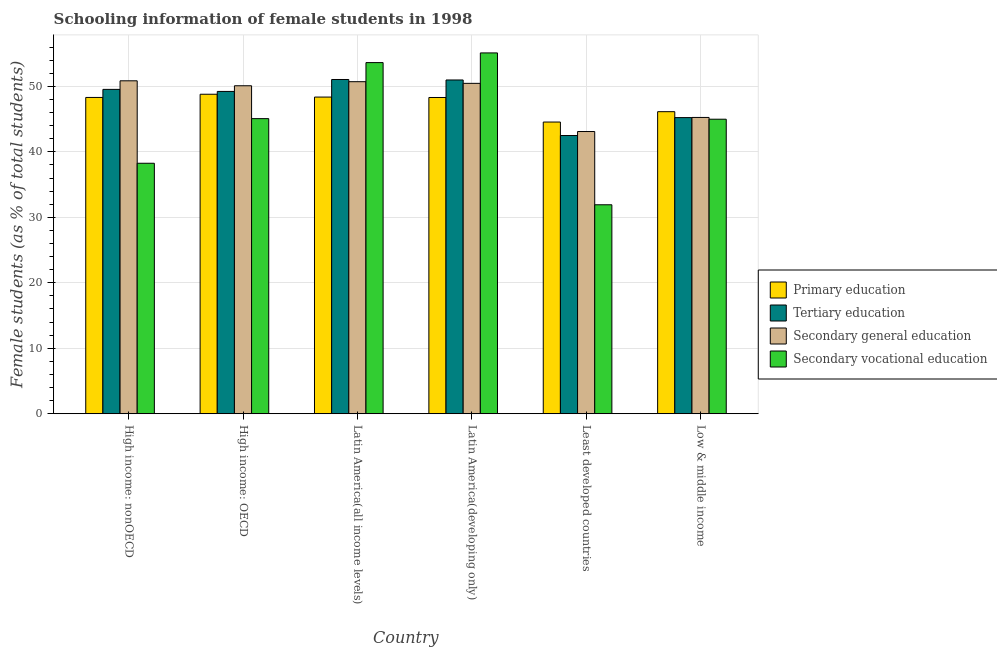How many different coloured bars are there?
Your answer should be very brief. 4. How many groups of bars are there?
Make the answer very short. 6. What is the label of the 5th group of bars from the left?
Your answer should be compact. Least developed countries. In how many cases, is the number of bars for a given country not equal to the number of legend labels?
Ensure brevity in your answer.  0. What is the percentage of female students in secondary education in Least developed countries?
Your answer should be compact. 43.11. Across all countries, what is the maximum percentage of female students in primary education?
Provide a short and direct response. 48.8. Across all countries, what is the minimum percentage of female students in secondary vocational education?
Offer a very short reply. 31.92. In which country was the percentage of female students in secondary education maximum?
Your answer should be very brief. High income: nonOECD. In which country was the percentage of female students in secondary vocational education minimum?
Offer a very short reply. Least developed countries. What is the total percentage of female students in tertiary education in the graph?
Give a very brief answer. 288.53. What is the difference between the percentage of female students in tertiary education in High income: nonOECD and that in Low & middle income?
Your response must be concise. 4.31. What is the difference between the percentage of female students in tertiary education in High income: nonOECD and the percentage of female students in secondary education in Low & middle income?
Make the answer very short. 4.28. What is the average percentage of female students in secondary education per country?
Provide a succinct answer. 48.42. What is the difference between the percentage of female students in secondary education and percentage of female students in tertiary education in Latin America(all income levels)?
Your answer should be very brief. -0.34. What is the ratio of the percentage of female students in primary education in Least developed countries to that in Low & middle income?
Provide a short and direct response. 0.97. Is the percentage of female students in secondary education in Latin America(developing only) less than that in Least developed countries?
Your answer should be very brief. No. What is the difference between the highest and the second highest percentage of female students in secondary education?
Ensure brevity in your answer.  0.14. What is the difference between the highest and the lowest percentage of female students in tertiary education?
Offer a very short reply. 8.56. In how many countries, is the percentage of female students in primary education greater than the average percentage of female students in primary education taken over all countries?
Your response must be concise. 4. Is it the case that in every country, the sum of the percentage of female students in secondary vocational education and percentage of female students in primary education is greater than the sum of percentage of female students in tertiary education and percentage of female students in secondary education?
Your answer should be compact. No. What does the 1st bar from the left in High income: OECD represents?
Provide a succinct answer. Primary education. What does the 1st bar from the right in High income: nonOECD represents?
Your answer should be compact. Secondary vocational education. How many bars are there?
Keep it short and to the point. 24. Are all the bars in the graph horizontal?
Give a very brief answer. No. What is the difference between two consecutive major ticks on the Y-axis?
Give a very brief answer. 10. How are the legend labels stacked?
Ensure brevity in your answer.  Vertical. What is the title of the graph?
Your response must be concise. Schooling information of female students in 1998. Does "Primary" appear as one of the legend labels in the graph?
Provide a succinct answer. No. What is the label or title of the X-axis?
Ensure brevity in your answer.  Country. What is the label or title of the Y-axis?
Your response must be concise. Female students (as % of total students). What is the Female students (as % of total students) of Primary education in High income: nonOECD?
Your response must be concise. 48.31. What is the Female students (as % of total students) of Tertiary education in High income: nonOECD?
Make the answer very short. 49.54. What is the Female students (as % of total students) of Secondary general education in High income: nonOECD?
Offer a very short reply. 50.85. What is the Female students (as % of total students) of Secondary vocational education in High income: nonOECD?
Your answer should be very brief. 38.26. What is the Female students (as % of total students) in Primary education in High income: OECD?
Your response must be concise. 48.8. What is the Female students (as % of total students) in Tertiary education in High income: OECD?
Your answer should be very brief. 49.23. What is the Female students (as % of total students) of Secondary general education in High income: OECD?
Give a very brief answer. 50.1. What is the Female students (as % of total students) of Secondary vocational education in High income: OECD?
Provide a short and direct response. 45.07. What is the Female students (as % of total students) in Primary education in Latin America(all income levels)?
Make the answer very short. 48.37. What is the Female students (as % of total students) in Tertiary education in Latin America(all income levels)?
Make the answer very short. 51.05. What is the Female students (as % of total students) of Secondary general education in Latin America(all income levels)?
Make the answer very short. 50.72. What is the Female students (as % of total students) of Secondary vocational education in Latin America(all income levels)?
Keep it short and to the point. 53.63. What is the Female students (as % of total students) in Primary education in Latin America(developing only)?
Give a very brief answer. 48.3. What is the Female students (as % of total students) of Tertiary education in Latin America(developing only)?
Your response must be concise. 50.98. What is the Female students (as % of total students) in Secondary general education in Latin America(developing only)?
Ensure brevity in your answer.  50.46. What is the Female students (as % of total students) in Secondary vocational education in Latin America(developing only)?
Make the answer very short. 55.11. What is the Female students (as % of total students) of Primary education in Least developed countries?
Your answer should be very brief. 44.55. What is the Female students (as % of total students) in Tertiary education in Least developed countries?
Give a very brief answer. 42.49. What is the Female students (as % of total students) in Secondary general education in Least developed countries?
Your response must be concise. 43.11. What is the Female students (as % of total students) in Secondary vocational education in Least developed countries?
Offer a terse response. 31.92. What is the Female students (as % of total students) in Primary education in Low & middle income?
Keep it short and to the point. 46.14. What is the Female students (as % of total students) in Tertiary education in Low & middle income?
Your answer should be compact. 45.23. What is the Female students (as % of total students) in Secondary general education in Low & middle income?
Provide a succinct answer. 45.26. What is the Female students (as % of total students) of Secondary vocational education in Low & middle income?
Keep it short and to the point. 44.99. Across all countries, what is the maximum Female students (as % of total students) in Primary education?
Give a very brief answer. 48.8. Across all countries, what is the maximum Female students (as % of total students) in Tertiary education?
Provide a short and direct response. 51.05. Across all countries, what is the maximum Female students (as % of total students) in Secondary general education?
Your response must be concise. 50.85. Across all countries, what is the maximum Female students (as % of total students) of Secondary vocational education?
Offer a very short reply. 55.11. Across all countries, what is the minimum Female students (as % of total students) in Primary education?
Your answer should be compact. 44.55. Across all countries, what is the minimum Female students (as % of total students) in Tertiary education?
Your response must be concise. 42.49. Across all countries, what is the minimum Female students (as % of total students) of Secondary general education?
Your response must be concise. 43.11. Across all countries, what is the minimum Female students (as % of total students) of Secondary vocational education?
Offer a terse response. 31.92. What is the total Female students (as % of total students) in Primary education in the graph?
Your response must be concise. 284.47. What is the total Female students (as % of total students) of Tertiary education in the graph?
Keep it short and to the point. 288.53. What is the total Female students (as % of total students) of Secondary general education in the graph?
Offer a very short reply. 290.49. What is the total Female students (as % of total students) of Secondary vocational education in the graph?
Provide a short and direct response. 268.98. What is the difference between the Female students (as % of total students) of Primary education in High income: nonOECD and that in High income: OECD?
Make the answer very short. -0.49. What is the difference between the Female students (as % of total students) in Tertiary education in High income: nonOECD and that in High income: OECD?
Provide a succinct answer. 0.31. What is the difference between the Female students (as % of total students) of Secondary general education in High income: nonOECD and that in High income: OECD?
Give a very brief answer. 0.76. What is the difference between the Female students (as % of total students) of Secondary vocational education in High income: nonOECD and that in High income: OECD?
Your answer should be compact. -6.81. What is the difference between the Female students (as % of total students) in Primary education in High income: nonOECD and that in Latin America(all income levels)?
Offer a terse response. -0.06. What is the difference between the Female students (as % of total students) of Tertiary education in High income: nonOECD and that in Latin America(all income levels)?
Make the answer very short. -1.51. What is the difference between the Female students (as % of total students) of Secondary general education in High income: nonOECD and that in Latin America(all income levels)?
Offer a very short reply. 0.14. What is the difference between the Female students (as % of total students) in Secondary vocational education in High income: nonOECD and that in Latin America(all income levels)?
Your response must be concise. -15.37. What is the difference between the Female students (as % of total students) of Primary education in High income: nonOECD and that in Latin America(developing only)?
Your response must be concise. 0.01. What is the difference between the Female students (as % of total students) of Tertiary education in High income: nonOECD and that in Latin America(developing only)?
Your response must be concise. -1.44. What is the difference between the Female students (as % of total students) of Secondary general education in High income: nonOECD and that in Latin America(developing only)?
Provide a succinct answer. 0.39. What is the difference between the Female students (as % of total students) in Secondary vocational education in High income: nonOECD and that in Latin America(developing only)?
Your answer should be compact. -16.85. What is the difference between the Female students (as % of total students) of Primary education in High income: nonOECD and that in Least developed countries?
Ensure brevity in your answer.  3.76. What is the difference between the Female students (as % of total students) of Tertiary education in High income: nonOECD and that in Least developed countries?
Keep it short and to the point. 7.05. What is the difference between the Female students (as % of total students) in Secondary general education in High income: nonOECD and that in Least developed countries?
Provide a succinct answer. 7.75. What is the difference between the Female students (as % of total students) of Secondary vocational education in High income: nonOECD and that in Least developed countries?
Your answer should be very brief. 6.34. What is the difference between the Female students (as % of total students) of Primary education in High income: nonOECD and that in Low & middle income?
Provide a short and direct response. 2.17. What is the difference between the Female students (as % of total students) in Tertiary education in High income: nonOECD and that in Low & middle income?
Give a very brief answer. 4.31. What is the difference between the Female students (as % of total students) of Secondary general education in High income: nonOECD and that in Low & middle income?
Keep it short and to the point. 5.6. What is the difference between the Female students (as % of total students) in Secondary vocational education in High income: nonOECD and that in Low & middle income?
Offer a very short reply. -6.73. What is the difference between the Female students (as % of total students) in Primary education in High income: OECD and that in Latin America(all income levels)?
Provide a short and direct response. 0.43. What is the difference between the Female students (as % of total students) in Tertiary education in High income: OECD and that in Latin America(all income levels)?
Give a very brief answer. -1.82. What is the difference between the Female students (as % of total students) in Secondary general education in High income: OECD and that in Latin America(all income levels)?
Keep it short and to the point. -0.62. What is the difference between the Female students (as % of total students) of Secondary vocational education in High income: OECD and that in Latin America(all income levels)?
Ensure brevity in your answer.  -8.56. What is the difference between the Female students (as % of total students) in Primary education in High income: OECD and that in Latin America(developing only)?
Offer a very short reply. 0.49. What is the difference between the Female students (as % of total students) in Tertiary education in High income: OECD and that in Latin America(developing only)?
Give a very brief answer. -1.75. What is the difference between the Female students (as % of total students) of Secondary general education in High income: OECD and that in Latin America(developing only)?
Your answer should be compact. -0.37. What is the difference between the Female students (as % of total students) of Secondary vocational education in High income: OECD and that in Latin America(developing only)?
Give a very brief answer. -10.04. What is the difference between the Female students (as % of total students) of Primary education in High income: OECD and that in Least developed countries?
Give a very brief answer. 4.25. What is the difference between the Female students (as % of total students) in Tertiary education in High income: OECD and that in Least developed countries?
Your response must be concise. 6.74. What is the difference between the Female students (as % of total students) of Secondary general education in High income: OECD and that in Least developed countries?
Your answer should be very brief. 6.99. What is the difference between the Female students (as % of total students) in Secondary vocational education in High income: OECD and that in Least developed countries?
Your answer should be compact. 13.16. What is the difference between the Female students (as % of total students) in Primary education in High income: OECD and that in Low & middle income?
Your response must be concise. 2.66. What is the difference between the Female students (as % of total students) in Tertiary education in High income: OECD and that in Low & middle income?
Provide a succinct answer. 4. What is the difference between the Female students (as % of total students) of Secondary general education in High income: OECD and that in Low & middle income?
Provide a succinct answer. 4.84. What is the difference between the Female students (as % of total students) in Secondary vocational education in High income: OECD and that in Low & middle income?
Provide a succinct answer. 0.09. What is the difference between the Female students (as % of total students) in Primary education in Latin America(all income levels) and that in Latin America(developing only)?
Offer a very short reply. 0.06. What is the difference between the Female students (as % of total students) in Tertiary education in Latin America(all income levels) and that in Latin America(developing only)?
Your answer should be compact. 0.07. What is the difference between the Female students (as % of total students) of Secondary general education in Latin America(all income levels) and that in Latin America(developing only)?
Provide a succinct answer. 0.25. What is the difference between the Female students (as % of total students) of Secondary vocational education in Latin America(all income levels) and that in Latin America(developing only)?
Provide a short and direct response. -1.48. What is the difference between the Female students (as % of total students) in Primary education in Latin America(all income levels) and that in Least developed countries?
Make the answer very short. 3.81. What is the difference between the Female students (as % of total students) of Tertiary education in Latin America(all income levels) and that in Least developed countries?
Your response must be concise. 8.56. What is the difference between the Female students (as % of total students) of Secondary general education in Latin America(all income levels) and that in Least developed countries?
Keep it short and to the point. 7.61. What is the difference between the Female students (as % of total students) in Secondary vocational education in Latin America(all income levels) and that in Least developed countries?
Offer a very short reply. 21.72. What is the difference between the Female students (as % of total students) of Primary education in Latin America(all income levels) and that in Low & middle income?
Ensure brevity in your answer.  2.23. What is the difference between the Female students (as % of total students) of Tertiary education in Latin America(all income levels) and that in Low & middle income?
Offer a terse response. 5.82. What is the difference between the Female students (as % of total students) of Secondary general education in Latin America(all income levels) and that in Low & middle income?
Provide a succinct answer. 5.46. What is the difference between the Female students (as % of total students) in Secondary vocational education in Latin America(all income levels) and that in Low & middle income?
Offer a terse response. 8.65. What is the difference between the Female students (as % of total students) of Primary education in Latin America(developing only) and that in Least developed countries?
Make the answer very short. 3.75. What is the difference between the Female students (as % of total students) of Tertiary education in Latin America(developing only) and that in Least developed countries?
Provide a succinct answer. 8.49. What is the difference between the Female students (as % of total students) in Secondary general education in Latin America(developing only) and that in Least developed countries?
Ensure brevity in your answer.  7.36. What is the difference between the Female students (as % of total students) in Secondary vocational education in Latin America(developing only) and that in Least developed countries?
Offer a very short reply. 23.2. What is the difference between the Female students (as % of total students) of Primary education in Latin America(developing only) and that in Low & middle income?
Your response must be concise. 2.17. What is the difference between the Female students (as % of total students) of Tertiary education in Latin America(developing only) and that in Low & middle income?
Keep it short and to the point. 5.75. What is the difference between the Female students (as % of total students) in Secondary general education in Latin America(developing only) and that in Low & middle income?
Ensure brevity in your answer.  5.21. What is the difference between the Female students (as % of total students) of Secondary vocational education in Latin America(developing only) and that in Low & middle income?
Provide a succinct answer. 10.13. What is the difference between the Female students (as % of total students) in Primary education in Least developed countries and that in Low & middle income?
Your answer should be compact. -1.58. What is the difference between the Female students (as % of total students) in Tertiary education in Least developed countries and that in Low & middle income?
Offer a very short reply. -2.74. What is the difference between the Female students (as % of total students) in Secondary general education in Least developed countries and that in Low & middle income?
Your answer should be very brief. -2.15. What is the difference between the Female students (as % of total students) in Secondary vocational education in Least developed countries and that in Low & middle income?
Make the answer very short. -13.07. What is the difference between the Female students (as % of total students) in Primary education in High income: nonOECD and the Female students (as % of total students) in Tertiary education in High income: OECD?
Give a very brief answer. -0.92. What is the difference between the Female students (as % of total students) in Primary education in High income: nonOECD and the Female students (as % of total students) in Secondary general education in High income: OECD?
Provide a short and direct response. -1.79. What is the difference between the Female students (as % of total students) of Primary education in High income: nonOECD and the Female students (as % of total students) of Secondary vocational education in High income: OECD?
Offer a very short reply. 3.24. What is the difference between the Female students (as % of total students) in Tertiary education in High income: nonOECD and the Female students (as % of total students) in Secondary general education in High income: OECD?
Your answer should be compact. -0.56. What is the difference between the Female students (as % of total students) in Tertiary education in High income: nonOECD and the Female students (as % of total students) in Secondary vocational education in High income: OECD?
Provide a short and direct response. 4.47. What is the difference between the Female students (as % of total students) of Secondary general education in High income: nonOECD and the Female students (as % of total students) of Secondary vocational education in High income: OECD?
Keep it short and to the point. 5.78. What is the difference between the Female students (as % of total students) of Primary education in High income: nonOECD and the Female students (as % of total students) of Tertiary education in Latin America(all income levels)?
Offer a very short reply. -2.74. What is the difference between the Female students (as % of total students) of Primary education in High income: nonOECD and the Female students (as % of total students) of Secondary general education in Latin America(all income levels)?
Make the answer very short. -2.41. What is the difference between the Female students (as % of total students) in Primary education in High income: nonOECD and the Female students (as % of total students) in Secondary vocational education in Latin America(all income levels)?
Keep it short and to the point. -5.32. What is the difference between the Female students (as % of total students) of Tertiary education in High income: nonOECD and the Female students (as % of total students) of Secondary general education in Latin America(all income levels)?
Your answer should be very brief. -1.17. What is the difference between the Female students (as % of total students) in Tertiary education in High income: nonOECD and the Female students (as % of total students) in Secondary vocational education in Latin America(all income levels)?
Your answer should be very brief. -4.09. What is the difference between the Female students (as % of total students) of Secondary general education in High income: nonOECD and the Female students (as % of total students) of Secondary vocational education in Latin America(all income levels)?
Make the answer very short. -2.78. What is the difference between the Female students (as % of total students) of Primary education in High income: nonOECD and the Female students (as % of total students) of Tertiary education in Latin America(developing only)?
Provide a succinct answer. -2.67. What is the difference between the Female students (as % of total students) of Primary education in High income: nonOECD and the Female students (as % of total students) of Secondary general education in Latin America(developing only)?
Ensure brevity in your answer.  -2.15. What is the difference between the Female students (as % of total students) in Primary education in High income: nonOECD and the Female students (as % of total students) in Secondary vocational education in Latin America(developing only)?
Keep it short and to the point. -6.8. What is the difference between the Female students (as % of total students) of Tertiary education in High income: nonOECD and the Female students (as % of total students) of Secondary general education in Latin America(developing only)?
Your answer should be very brief. -0.92. What is the difference between the Female students (as % of total students) of Tertiary education in High income: nonOECD and the Female students (as % of total students) of Secondary vocational education in Latin America(developing only)?
Provide a short and direct response. -5.57. What is the difference between the Female students (as % of total students) in Secondary general education in High income: nonOECD and the Female students (as % of total students) in Secondary vocational education in Latin America(developing only)?
Your response must be concise. -4.26. What is the difference between the Female students (as % of total students) in Primary education in High income: nonOECD and the Female students (as % of total students) in Tertiary education in Least developed countries?
Offer a terse response. 5.82. What is the difference between the Female students (as % of total students) of Primary education in High income: nonOECD and the Female students (as % of total students) of Secondary general education in Least developed countries?
Your answer should be very brief. 5.2. What is the difference between the Female students (as % of total students) in Primary education in High income: nonOECD and the Female students (as % of total students) in Secondary vocational education in Least developed countries?
Keep it short and to the point. 16.39. What is the difference between the Female students (as % of total students) in Tertiary education in High income: nonOECD and the Female students (as % of total students) in Secondary general education in Least developed countries?
Your answer should be very brief. 6.44. What is the difference between the Female students (as % of total students) in Tertiary education in High income: nonOECD and the Female students (as % of total students) in Secondary vocational education in Least developed countries?
Make the answer very short. 17.62. What is the difference between the Female students (as % of total students) of Secondary general education in High income: nonOECD and the Female students (as % of total students) of Secondary vocational education in Least developed countries?
Give a very brief answer. 18.94. What is the difference between the Female students (as % of total students) of Primary education in High income: nonOECD and the Female students (as % of total students) of Tertiary education in Low & middle income?
Give a very brief answer. 3.08. What is the difference between the Female students (as % of total students) in Primary education in High income: nonOECD and the Female students (as % of total students) in Secondary general education in Low & middle income?
Offer a terse response. 3.05. What is the difference between the Female students (as % of total students) in Primary education in High income: nonOECD and the Female students (as % of total students) in Secondary vocational education in Low & middle income?
Provide a succinct answer. 3.32. What is the difference between the Female students (as % of total students) in Tertiary education in High income: nonOECD and the Female students (as % of total students) in Secondary general education in Low & middle income?
Give a very brief answer. 4.28. What is the difference between the Female students (as % of total students) in Tertiary education in High income: nonOECD and the Female students (as % of total students) in Secondary vocational education in Low & middle income?
Your answer should be compact. 4.55. What is the difference between the Female students (as % of total students) of Secondary general education in High income: nonOECD and the Female students (as % of total students) of Secondary vocational education in Low & middle income?
Keep it short and to the point. 5.87. What is the difference between the Female students (as % of total students) of Primary education in High income: OECD and the Female students (as % of total students) of Tertiary education in Latin America(all income levels)?
Keep it short and to the point. -2.25. What is the difference between the Female students (as % of total students) of Primary education in High income: OECD and the Female students (as % of total students) of Secondary general education in Latin America(all income levels)?
Make the answer very short. -1.92. What is the difference between the Female students (as % of total students) of Primary education in High income: OECD and the Female students (as % of total students) of Secondary vocational education in Latin America(all income levels)?
Make the answer very short. -4.83. What is the difference between the Female students (as % of total students) in Tertiary education in High income: OECD and the Female students (as % of total students) in Secondary general education in Latin America(all income levels)?
Provide a short and direct response. -1.49. What is the difference between the Female students (as % of total students) in Tertiary education in High income: OECD and the Female students (as % of total students) in Secondary vocational education in Latin America(all income levels)?
Your answer should be very brief. -4.4. What is the difference between the Female students (as % of total students) in Secondary general education in High income: OECD and the Female students (as % of total students) in Secondary vocational education in Latin America(all income levels)?
Give a very brief answer. -3.54. What is the difference between the Female students (as % of total students) of Primary education in High income: OECD and the Female students (as % of total students) of Tertiary education in Latin America(developing only)?
Ensure brevity in your answer.  -2.18. What is the difference between the Female students (as % of total students) of Primary education in High income: OECD and the Female students (as % of total students) of Secondary general education in Latin America(developing only)?
Your response must be concise. -1.66. What is the difference between the Female students (as % of total students) of Primary education in High income: OECD and the Female students (as % of total students) of Secondary vocational education in Latin America(developing only)?
Provide a short and direct response. -6.31. What is the difference between the Female students (as % of total students) of Tertiary education in High income: OECD and the Female students (as % of total students) of Secondary general education in Latin America(developing only)?
Provide a succinct answer. -1.23. What is the difference between the Female students (as % of total students) in Tertiary education in High income: OECD and the Female students (as % of total students) in Secondary vocational education in Latin America(developing only)?
Keep it short and to the point. -5.88. What is the difference between the Female students (as % of total students) of Secondary general education in High income: OECD and the Female students (as % of total students) of Secondary vocational education in Latin America(developing only)?
Your answer should be very brief. -5.02. What is the difference between the Female students (as % of total students) in Primary education in High income: OECD and the Female students (as % of total students) in Tertiary education in Least developed countries?
Provide a succinct answer. 6.31. What is the difference between the Female students (as % of total students) of Primary education in High income: OECD and the Female students (as % of total students) of Secondary general education in Least developed countries?
Your response must be concise. 5.69. What is the difference between the Female students (as % of total students) of Primary education in High income: OECD and the Female students (as % of total students) of Secondary vocational education in Least developed countries?
Keep it short and to the point. 16.88. What is the difference between the Female students (as % of total students) in Tertiary education in High income: OECD and the Female students (as % of total students) in Secondary general education in Least developed countries?
Provide a succinct answer. 6.12. What is the difference between the Female students (as % of total students) of Tertiary education in High income: OECD and the Female students (as % of total students) of Secondary vocational education in Least developed countries?
Make the answer very short. 17.31. What is the difference between the Female students (as % of total students) in Secondary general education in High income: OECD and the Female students (as % of total students) in Secondary vocational education in Least developed countries?
Offer a very short reply. 18.18. What is the difference between the Female students (as % of total students) of Primary education in High income: OECD and the Female students (as % of total students) of Tertiary education in Low & middle income?
Your response must be concise. 3.57. What is the difference between the Female students (as % of total students) in Primary education in High income: OECD and the Female students (as % of total students) in Secondary general education in Low & middle income?
Ensure brevity in your answer.  3.54. What is the difference between the Female students (as % of total students) of Primary education in High income: OECD and the Female students (as % of total students) of Secondary vocational education in Low & middle income?
Give a very brief answer. 3.81. What is the difference between the Female students (as % of total students) in Tertiary education in High income: OECD and the Female students (as % of total students) in Secondary general education in Low & middle income?
Your answer should be very brief. 3.97. What is the difference between the Female students (as % of total students) in Tertiary education in High income: OECD and the Female students (as % of total students) in Secondary vocational education in Low & middle income?
Provide a short and direct response. 4.24. What is the difference between the Female students (as % of total students) in Secondary general education in High income: OECD and the Female students (as % of total students) in Secondary vocational education in Low & middle income?
Your answer should be very brief. 5.11. What is the difference between the Female students (as % of total students) in Primary education in Latin America(all income levels) and the Female students (as % of total students) in Tertiary education in Latin America(developing only)?
Keep it short and to the point. -2.61. What is the difference between the Female students (as % of total students) in Primary education in Latin America(all income levels) and the Female students (as % of total students) in Secondary general education in Latin America(developing only)?
Provide a short and direct response. -2.1. What is the difference between the Female students (as % of total students) in Primary education in Latin America(all income levels) and the Female students (as % of total students) in Secondary vocational education in Latin America(developing only)?
Provide a short and direct response. -6.74. What is the difference between the Female students (as % of total students) in Tertiary education in Latin America(all income levels) and the Female students (as % of total students) in Secondary general education in Latin America(developing only)?
Provide a succinct answer. 0.59. What is the difference between the Female students (as % of total students) of Tertiary education in Latin America(all income levels) and the Female students (as % of total students) of Secondary vocational education in Latin America(developing only)?
Provide a succinct answer. -4.06. What is the difference between the Female students (as % of total students) of Secondary general education in Latin America(all income levels) and the Female students (as % of total students) of Secondary vocational education in Latin America(developing only)?
Provide a short and direct response. -4.4. What is the difference between the Female students (as % of total students) in Primary education in Latin America(all income levels) and the Female students (as % of total students) in Tertiary education in Least developed countries?
Offer a terse response. 5.87. What is the difference between the Female students (as % of total students) of Primary education in Latin America(all income levels) and the Female students (as % of total students) of Secondary general education in Least developed countries?
Make the answer very short. 5.26. What is the difference between the Female students (as % of total students) in Primary education in Latin America(all income levels) and the Female students (as % of total students) in Secondary vocational education in Least developed countries?
Give a very brief answer. 16.45. What is the difference between the Female students (as % of total students) in Tertiary education in Latin America(all income levels) and the Female students (as % of total students) in Secondary general education in Least developed countries?
Provide a short and direct response. 7.95. What is the difference between the Female students (as % of total students) in Tertiary education in Latin America(all income levels) and the Female students (as % of total students) in Secondary vocational education in Least developed countries?
Your answer should be compact. 19.14. What is the difference between the Female students (as % of total students) in Secondary general education in Latin America(all income levels) and the Female students (as % of total students) in Secondary vocational education in Least developed countries?
Your response must be concise. 18.8. What is the difference between the Female students (as % of total students) in Primary education in Latin America(all income levels) and the Female students (as % of total students) in Tertiary education in Low & middle income?
Make the answer very short. 3.14. What is the difference between the Female students (as % of total students) in Primary education in Latin America(all income levels) and the Female students (as % of total students) in Secondary general education in Low & middle income?
Make the answer very short. 3.11. What is the difference between the Female students (as % of total students) in Primary education in Latin America(all income levels) and the Female students (as % of total students) in Secondary vocational education in Low & middle income?
Your answer should be very brief. 3.38. What is the difference between the Female students (as % of total students) of Tertiary education in Latin America(all income levels) and the Female students (as % of total students) of Secondary general education in Low & middle income?
Provide a short and direct response. 5.8. What is the difference between the Female students (as % of total students) of Tertiary education in Latin America(all income levels) and the Female students (as % of total students) of Secondary vocational education in Low & middle income?
Offer a terse response. 6.07. What is the difference between the Female students (as % of total students) of Secondary general education in Latin America(all income levels) and the Female students (as % of total students) of Secondary vocational education in Low & middle income?
Your response must be concise. 5.73. What is the difference between the Female students (as % of total students) in Primary education in Latin America(developing only) and the Female students (as % of total students) in Tertiary education in Least developed countries?
Provide a short and direct response. 5.81. What is the difference between the Female students (as % of total students) of Primary education in Latin America(developing only) and the Female students (as % of total students) of Secondary general education in Least developed countries?
Provide a short and direct response. 5.2. What is the difference between the Female students (as % of total students) of Primary education in Latin America(developing only) and the Female students (as % of total students) of Secondary vocational education in Least developed countries?
Your answer should be compact. 16.39. What is the difference between the Female students (as % of total students) of Tertiary education in Latin America(developing only) and the Female students (as % of total students) of Secondary general education in Least developed countries?
Make the answer very short. 7.87. What is the difference between the Female students (as % of total students) of Tertiary education in Latin America(developing only) and the Female students (as % of total students) of Secondary vocational education in Least developed countries?
Keep it short and to the point. 19.06. What is the difference between the Female students (as % of total students) of Secondary general education in Latin America(developing only) and the Female students (as % of total students) of Secondary vocational education in Least developed countries?
Your answer should be very brief. 18.55. What is the difference between the Female students (as % of total students) in Primary education in Latin America(developing only) and the Female students (as % of total students) in Tertiary education in Low & middle income?
Offer a very short reply. 3.07. What is the difference between the Female students (as % of total students) of Primary education in Latin America(developing only) and the Female students (as % of total students) of Secondary general education in Low & middle income?
Your answer should be compact. 3.05. What is the difference between the Female students (as % of total students) of Primary education in Latin America(developing only) and the Female students (as % of total students) of Secondary vocational education in Low & middle income?
Make the answer very short. 3.32. What is the difference between the Female students (as % of total students) of Tertiary education in Latin America(developing only) and the Female students (as % of total students) of Secondary general education in Low & middle income?
Your response must be concise. 5.72. What is the difference between the Female students (as % of total students) of Tertiary education in Latin America(developing only) and the Female students (as % of total students) of Secondary vocational education in Low & middle income?
Ensure brevity in your answer.  5.99. What is the difference between the Female students (as % of total students) in Secondary general education in Latin America(developing only) and the Female students (as % of total students) in Secondary vocational education in Low & middle income?
Your answer should be compact. 5.48. What is the difference between the Female students (as % of total students) in Primary education in Least developed countries and the Female students (as % of total students) in Tertiary education in Low & middle income?
Offer a terse response. -0.68. What is the difference between the Female students (as % of total students) of Primary education in Least developed countries and the Female students (as % of total students) of Secondary general education in Low & middle income?
Your response must be concise. -0.7. What is the difference between the Female students (as % of total students) in Primary education in Least developed countries and the Female students (as % of total students) in Secondary vocational education in Low & middle income?
Ensure brevity in your answer.  -0.43. What is the difference between the Female students (as % of total students) of Tertiary education in Least developed countries and the Female students (as % of total students) of Secondary general education in Low & middle income?
Make the answer very short. -2.76. What is the difference between the Female students (as % of total students) in Tertiary education in Least developed countries and the Female students (as % of total students) in Secondary vocational education in Low & middle income?
Offer a very short reply. -2.49. What is the difference between the Female students (as % of total students) of Secondary general education in Least developed countries and the Female students (as % of total students) of Secondary vocational education in Low & middle income?
Offer a terse response. -1.88. What is the average Female students (as % of total students) in Primary education per country?
Provide a succinct answer. 47.41. What is the average Female students (as % of total students) in Tertiary education per country?
Make the answer very short. 48.09. What is the average Female students (as % of total students) in Secondary general education per country?
Your answer should be compact. 48.42. What is the average Female students (as % of total students) of Secondary vocational education per country?
Provide a succinct answer. 44.83. What is the difference between the Female students (as % of total students) in Primary education and Female students (as % of total students) in Tertiary education in High income: nonOECD?
Give a very brief answer. -1.23. What is the difference between the Female students (as % of total students) of Primary education and Female students (as % of total students) of Secondary general education in High income: nonOECD?
Give a very brief answer. -2.54. What is the difference between the Female students (as % of total students) of Primary education and Female students (as % of total students) of Secondary vocational education in High income: nonOECD?
Offer a very short reply. 10.05. What is the difference between the Female students (as % of total students) in Tertiary education and Female students (as % of total students) in Secondary general education in High income: nonOECD?
Your answer should be compact. -1.31. What is the difference between the Female students (as % of total students) in Tertiary education and Female students (as % of total students) in Secondary vocational education in High income: nonOECD?
Your response must be concise. 11.28. What is the difference between the Female students (as % of total students) in Secondary general education and Female students (as % of total students) in Secondary vocational education in High income: nonOECD?
Provide a succinct answer. 12.59. What is the difference between the Female students (as % of total students) of Primary education and Female students (as % of total students) of Tertiary education in High income: OECD?
Provide a succinct answer. -0.43. What is the difference between the Female students (as % of total students) in Primary education and Female students (as % of total students) in Secondary general education in High income: OECD?
Offer a terse response. -1.3. What is the difference between the Female students (as % of total students) of Primary education and Female students (as % of total students) of Secondary vocational education in High income: OECD?
Offer a very short reply. 3.73. What is the difference between the Female students (as % of total students) in Tertiary education and Female students (as % of total students) in Secondary general education in High income: OECD?
Offer a terse response. -0.87. What is the difference between the Female students (as % of total students) of Tertiary education and Female students (as % of total students) of Secondary vocational education in High income: OECD?
Offer a very short reply. 4.16. What is the difference between the Female students (as % of total students) of Secondary general education and Female students (as % of total students) of Secondary vocational education in High income: OECD?
Ensure brevity in your answer.  5.02. What is the difference between the Female students (as % of total students) of Primary education and Female students (as % of total students) of Tertiary education in Latin America(all income levels)?
Your response must be concise. -2.68. What is the difference between the Female students (as % of total students) of Primary education and Female students (as % of total students) of Secondary general education in Latin America(all income levels)?
Offer a terse response. -2.35. What is the difference between the Female students (as % of total students) in Primary education and Female students (as % of total students) in Secondary vocational education in Latin America(all income levels)?
Provide a short and direct response. -5.26. What is the difference between the Female students (as % of total students) of Tertiary education and Female students (as % of total students) of Secondary general education in Latin America(all income levels)?
Your answer should be very brief. 0.34. What is the difference between the Female students (as % of total students) in Tertiary education and Female students (as % of total students) in Secondary vocational education in Latin America(all income levels)?
Keep it short and to the point. -2.58. What is the difference between the Female students (as % of total students) in Secondary general education and Female students (as % of total students) in Secondary vocational education in Latin America(all income levels)?
Give a very brief answer. -2.92. What is the difference between the Female students (as % of total students) in Primary education and Female students (as % of total students) in Tertiary education in Latin America(developing only)?
Keep it short and to the point. -2.67. What is the difference between the Female students (as % of total students) in Primary education and Female students (as % of total students) in Secondary general education in Latin America(developing only)?
Keep it short and to the point. -2.16. What is the difference between the Female students (as % of total students) of Primary education and Female students (as % of total students) of Secondary vocational education in Latin America(developing only)?
Provide a succinct answer. -6.81. What is the difference between the Female students (as % of total students) in Tertiary education and Female students (as % of total students) in Secondary general education in Latin America(developing only)?
Make the answer very short. 0.52. What is the difference between the Female students (as % of total students) of Tertiary education and Female students (as % of total students) of Secondary vocational education in Latin America(developing only)?
Offer a terse response. -4.13. What is the difference between the Female students (as % of total students) in Secondary general education and Female students (as % of total students) in Secondary vocational education in Latin America(developing only)?
Keep it short and to the point. -4.65. What is the difference between the Female students (as % of total students) of Primary education and Female students (as % of total students) of Tertiary education in Least developed countries?
Keep it short and to the point. 2.06. What is the difference between the Female students (as % of total students) of Primary education and Female students (as % of total students) of Secondary general education in Least developed countries?
Your response must be concise. 1.45. What is the difference between the Female students (as % of total students) in Primary education and Female students (as % of total students) in Secondary vocational education in Least developed countries?
Provide a succinct answer. 12.64. What is the difference between the Female students (as % of total students) of Tertiary education and Female students (as % of total students) of Secondary general education in Least developed countries?
Your response must be concise. -0.61. What is the difference between the Female students (as % of total students) in Tertiary education and Female students (as % of total students) in Secondary vocational education in Least developed countries?
Provide a succinct answer. 10.58. What is the difference between the Female students (as % of total students) of Secondary general education and Female students (as % of total students) of Secondary vocational education in Least developed countries?
Offer a terse response. 11.19. What is the difference between the Female students (as % of total students) of Primary education and Female students (as % of total students) of Tertiary education in Low & middle income?
Provide a short and direct response. 0.9. What is the difference between the Female students (as % of total students) of Primary education and Female students (as % of total students) of Secondary general education in Low & middle income?
Offer a very short reply. 0.88. What is the difference between the Female students (as % of total students) in Primary education and Female students (as % of total students) in Secondary vocational education in Low & middle income?
Provide a short and direct response. 1.15. What is the difference between the Female students (as % of total students) of Tertiary education and Female students (as % of total students) of Secondary general education in Low & middle income?
Your answer should be very brief. -0.03. What is the difference between the Female students (as % of total students) of Tertiary education and Female students (as % of total students) of Secondary vocational education in Low & middle income?
Make the answer very short. 0.25. What is the difference between the Female students (as % of total students) of Secondary general education and Female students (as % of total students) of Secondary vocational education in Low & middle income?
Provide a short and direct response. 0.27. What is the ratio of the Female students (as % of total students) of Primary education in High income: nonOECD to that in High income: OECD?
Offer a very short reply. 0.99. What is the ratio of the Female students (as % of total students) in Secondary general education in High income: nonOECD to that in High income: OECD?
Ensure brevity in your answer.  1.02. What is the ratio of the Female students (as % of total students) of Secondary vocational education in High income: nonOECD to that in High income: OECD?
Provide a succinct answer. 0.85. What is the ratio of the Female students (as % of total students) of Primary education in High income: nonOECD to that in Latin America(all income levels)?
Your response must be concise. 1. What is the ratio of the Female students (as % of total students) in Tertiary education in High income: nonOECD to that in Latin America(all income levels)?
Give a very brief answer. 0.97. What is the ratio of the Female students (as % of total students) in Secondary vocational education in High income: nonOECD to that in Latin America(all income levels)?
Your answer should be compact. 0.71. What is the ratio of the Female students (as % of total students) in Primary education in High income: nonOECD to that in Latin America(developing only)?
Give a very brief answer. 1. What is the ratio of the Female students (as % of total students) of Tertiary education in High income: nonOECD to that in Latin America(developing only)?
Provide a succinct answer. 0.97. What is the ratio of the Female students (as % of total students) in Secondary general education in High income: nonOECD to that in Latin America(developing only)?
Make the answer very short. 1.01. What is the ratio of the Female students (as % of total students) of Secondary vocational education in High income: nonOECD to that in Latin America(developing only)?
Your response must be concise. 0.69. What is the ratio of the Female students (as % of total students) in Primary education in High income: nonOECD to that in Least developed countries?
Your answer should be very brief. 1.08. What is the ratio of the Female students (as % of total students) in Tertiary education in High income: nonOECD to that in Least developed countries?
Ensure brevity in your answer.  1.17. What is the ratio of the Female students (as % of total students) in Secondary general education in High income: nonOECD to that in Least developed countries?
Make the answer very short. 1.18. What is the ratio of the Female students (as % of total students) of Secondary vocational education in High income: nonOECD to that in Least developed countries?
Your response must be concise. 1.2. What is the ratio of the Female students (as % of total students) in Primary education in High income: nonOECD to that in Low & middle income?
Your response must be concise. 1.05. What is the ratio of the Female students (as % of total students) in Tertiary education in High income: nonOECD to that in Low & middle income?
Offer a very short reply. 1.1. What is the ratio of the Female students (as % of total students) in Secondary general education in High income: nonOECD to that in Low & middle income?
Offer a very short reply. 1.12. What is the ratio of the Female students (as % of total students) of Secondary vocational education in High income: nonOECD to that in Low & middle income?
Your answer should be very brief. 0.85. What is the ratio of the Female students (as % of total students) in Primary education in High income: OECD to that in Latin America(all income levels)?
Ensure brevity in your answer.  1.01. What is the ratio of the Female students (as % of total students) in Tertiary education in High income: OECD to that in Latin America(all income levels)?
Your answer should be very brief. 0.96. What is the ratio of the Female students (as % of total students) in Secondary general education in High income: OECD to that in Latin America(all income levels)?
Ensure brevity in your answer.  0.99. What is the ratio of the Female students (as % of total students) of Secondary vocational education in High income: OECD to that in Latin America(all income levels)?
Keep it short and to the point. 0.84. What is the ratio of the Female students (as % of total students) in Primary education in High income: OECD to that in Latin America(developing only)?
Offer a very short reply. 1.01. What is the ratio of the Female students (as % of total students) in Tertiary education in High income: OECD to that in Latin America(developing only)?
Provide a short and direct response. 0.97. What is the ratio of the Female students (as % of total students) of Secondary vocational education in High income: OECD to that in Latin America(developing only)?
Your answer should be compact. 0.82. What is the ratio of the Female students (as % of total students) in Primary education in High income: OECD to that in Least developed countries?
Keep it short and to the point. 1.1. What is the ratio of the Female students (as % of total students) in Tertiary education in High income: OECD to that in Least developed countries?
Your response must be concise. 1.16. What is the ratio of the Female students (as % of total students) of Secondary general education in High income: OECD to that in Least developed countries?
Offer a very short reply. 1.16. What is the ratio of the Female students (as % of total students) of Secondary vocational education in High income: OECD to that in Least developed countries?
Keep it short and to the point. 1.41. What is the ratio of the Female students (as % of total students) of Primary education in High income: OECD to that in Low & middle income?
Provide a short and direct response. 1.06. What is the ratio of the Female students (as % of total students) in Tertiary education in High income: OECD to that in Low & middle income?
Give a very brief answer. 1.09. What is the ratio of the Female students (as % of total students) in Secondary general education in High income: OECD to that in Low & middle income?
Keep it short and to the point. 1.11. What is the ratio of the Female students (as % of total students) of Secondary vocational education in High income: OECD to that in Low & middle income?
Provide a short and direct response. 1. What is the ratio of the Female students (as % of total students) in Primary education in Latin America(all income levels) to that in Latin America(developing only)?
Ensure brevity in your answer.  1. What is the ratio of the Female students (as % of total students) in Secondary vocational education in Latin America(all income levels) to that in Latin America(developing only)?
Offer a very short reply. 0.97. What is the ratio of the Female students (as % of total students) in Primary education in Latin America(all income levels) to that in Least developed countries?
Your answer should be compact. 1.09. What is the ratio of the Female students (as % of total students) in Tertiary education in Latin America(all income levels) to that in Least developed countries?
Provide a short and direct response. 1.2. What is the ratio of the Female students (as % of total students) of Secondary general education in Latin America(all income levels) to that in Least developed countries?
Offer a very short reply. 1.18. What is the ratio of the Female students (as % of total students) of Secondary vocational education in Latin America(all income levels) to that in Least developed countries?
Your response must be concise. 1.68. What is the ratio of the Female students (as % of total students) of Primary education in Latin America(all income levels) to that in Low & middle income?
Make the answer very short. 1.05. What is the ratio of the Female students (as % of total students) in Tertiary education in Latin America(all income levels) to that in Low & middle income?
Provide a succinct answer. 1.13. What is the ratio of the Female students (as % of total students) in Secondary general education in Latin America(all income levels) to that in Low & middle income?
Make the answer very short. 1.12. What is the ratio of the Female students (as % of total students) of Secondary vocational education in Latin America(all income levels) to that in Low & middle income?
Your answer should be very brief. 1.19. What is the ratio of the Female students (as % of total students) in Primary education in Latin America(developing only) to that in Least developed countries?
Keep it short and to the point. 1.08. What is the ratio of the Female students (as % of total students) of Tertiary education in Latin America(developing only) to that in Least developed countries?
Your answer should be very brief. 1.2. What is the ratio of the Female students (as % of total students) of Secondary general education in Latin America(developing only) to that in Least developed countries?
Ensure brevity in your answer.  1.17. What is the ratio of the Female students (as % of total students) of Secondary vocational education in Latin America(developing only) to that in Least developed countries?
Give a very brief answer. 1.73. What is the ratio of the Female students (as % of total students) in Primary education in Latin America(developing only) to that in Low & middle income?
Offer a very short reply. 1.05. What is the ratio of the Female students (as % of total students) in Tertiary education in Latin America(developing only) to that in Low & middle income?
Make the answer very short. 1.13. What is the ratio of the Female students (as % of total students) in Secondary general education in Latin America(developing only) to that in Low & middle income?
Provide a short and direct response. 1.11. What is the ratio of the Female students (as % of total students) of Secondary vocational education in Latin America(developing only) to that in Low & middle income?
Your answer should be very brief. 1.23. What is the ratio of the Female students (as % of total students) of Primary education in Least developed countries to that in Low & middle income?
Make the answer very short. 0.97. What is the ratio of the Female students (as % of total students) of Tertiary education in Least developed countries to that in Low & middle income?
Your response must be concise. 0.94. What is the ratio of the Female students (as % of total students) in Secondary general education in Least developed countries to that in Low & middle income?
Provide a short and direct response. 0.95. What is the ratio of the Female students (as % of total students) of Secondary vocational education in Least developed countries to that in Low & middle income?
Your answer should be very brief. 0.71. What is the difference between the highest and the second highest Female students (as % of total students) in Primary education?
Offer a very short reply. 0.43. What is the difference between the highest and the second highest Female students (as % of total students) in Tertiary education?
Provide a short and direct response. 0.07. What is the difference between the highest and the second highest Female students (as % of total students) of Secondary general education?
Give a very brief answer. 0.14. What is the difference between the highest and the second highest Female students (as % of total students) of Secondary vocational education?
Ensure brevity in your answer.  1.48. What is the difference between the highest and the lowest Female students (as % of total students) of Primary education?
Your response must be concise. 4.25. What is the difference between the highest and the lowest Female students (as % of total students) of Tertiary education?
Provide a succinct answer. 8.56. What is the difference between the highest and the lowest Female students (as % of total students) of Secondary general education?
Give a very brief answer. 7.75. What is the difference between the highest and the lowest Female students (as % of total students) of Secondary vocational education?
Make the answer very short. 23.2. 